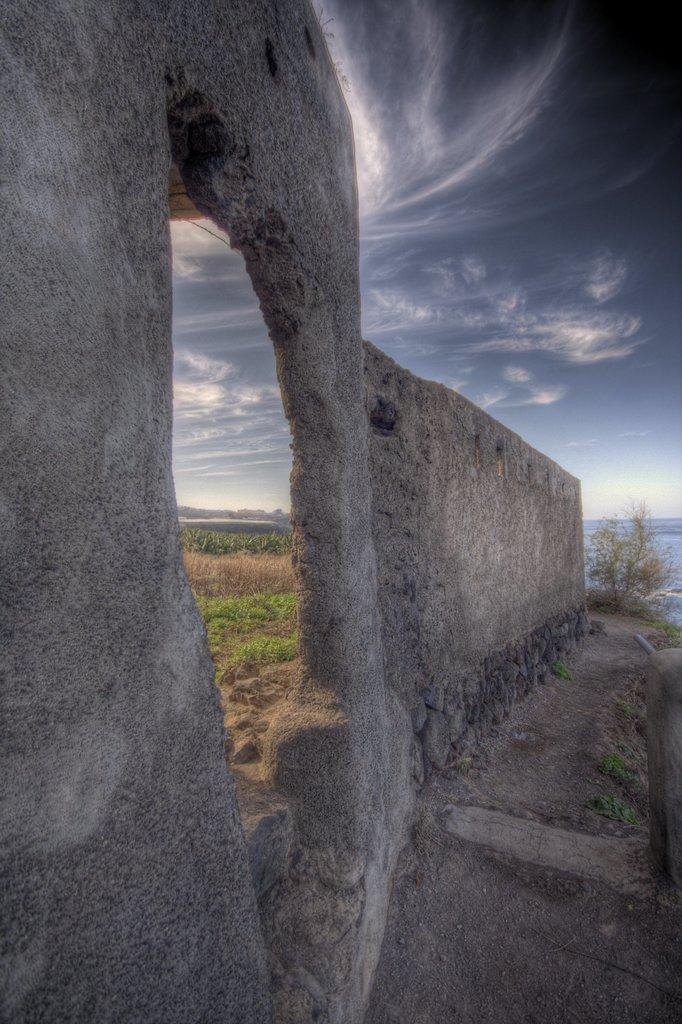What type of structure can be seen in the image? There is a wall in the image. What type of plant is present in the image? There is a tree in the image. What type of vegetation is visible in the image? There is grass visible in the image. What can be seen in the background of the image? There is water and the sky visible in the background of the image. What direction is the kitty facing in the image? There is no kitty present in the image. What statement is being made by the tree in the image? Trees do not make statements; they are plants. 